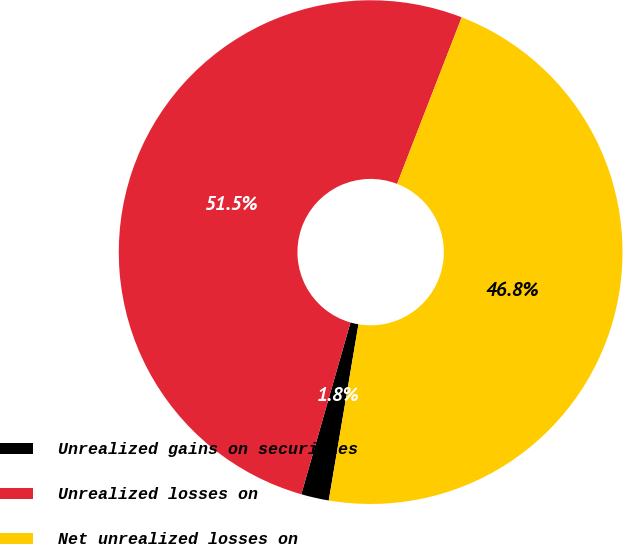Convert chart to OTSL. <chart><loc_0><loc_0><loc_500><loc_500><pie_chart><fcel>Unrealized gains on securities<fcel>Unrealized losses on<fcel>Net unrealized losses on<nl><fcel>1.78%<fcel>51.45%<fcel>46.77%<nl></chart> 